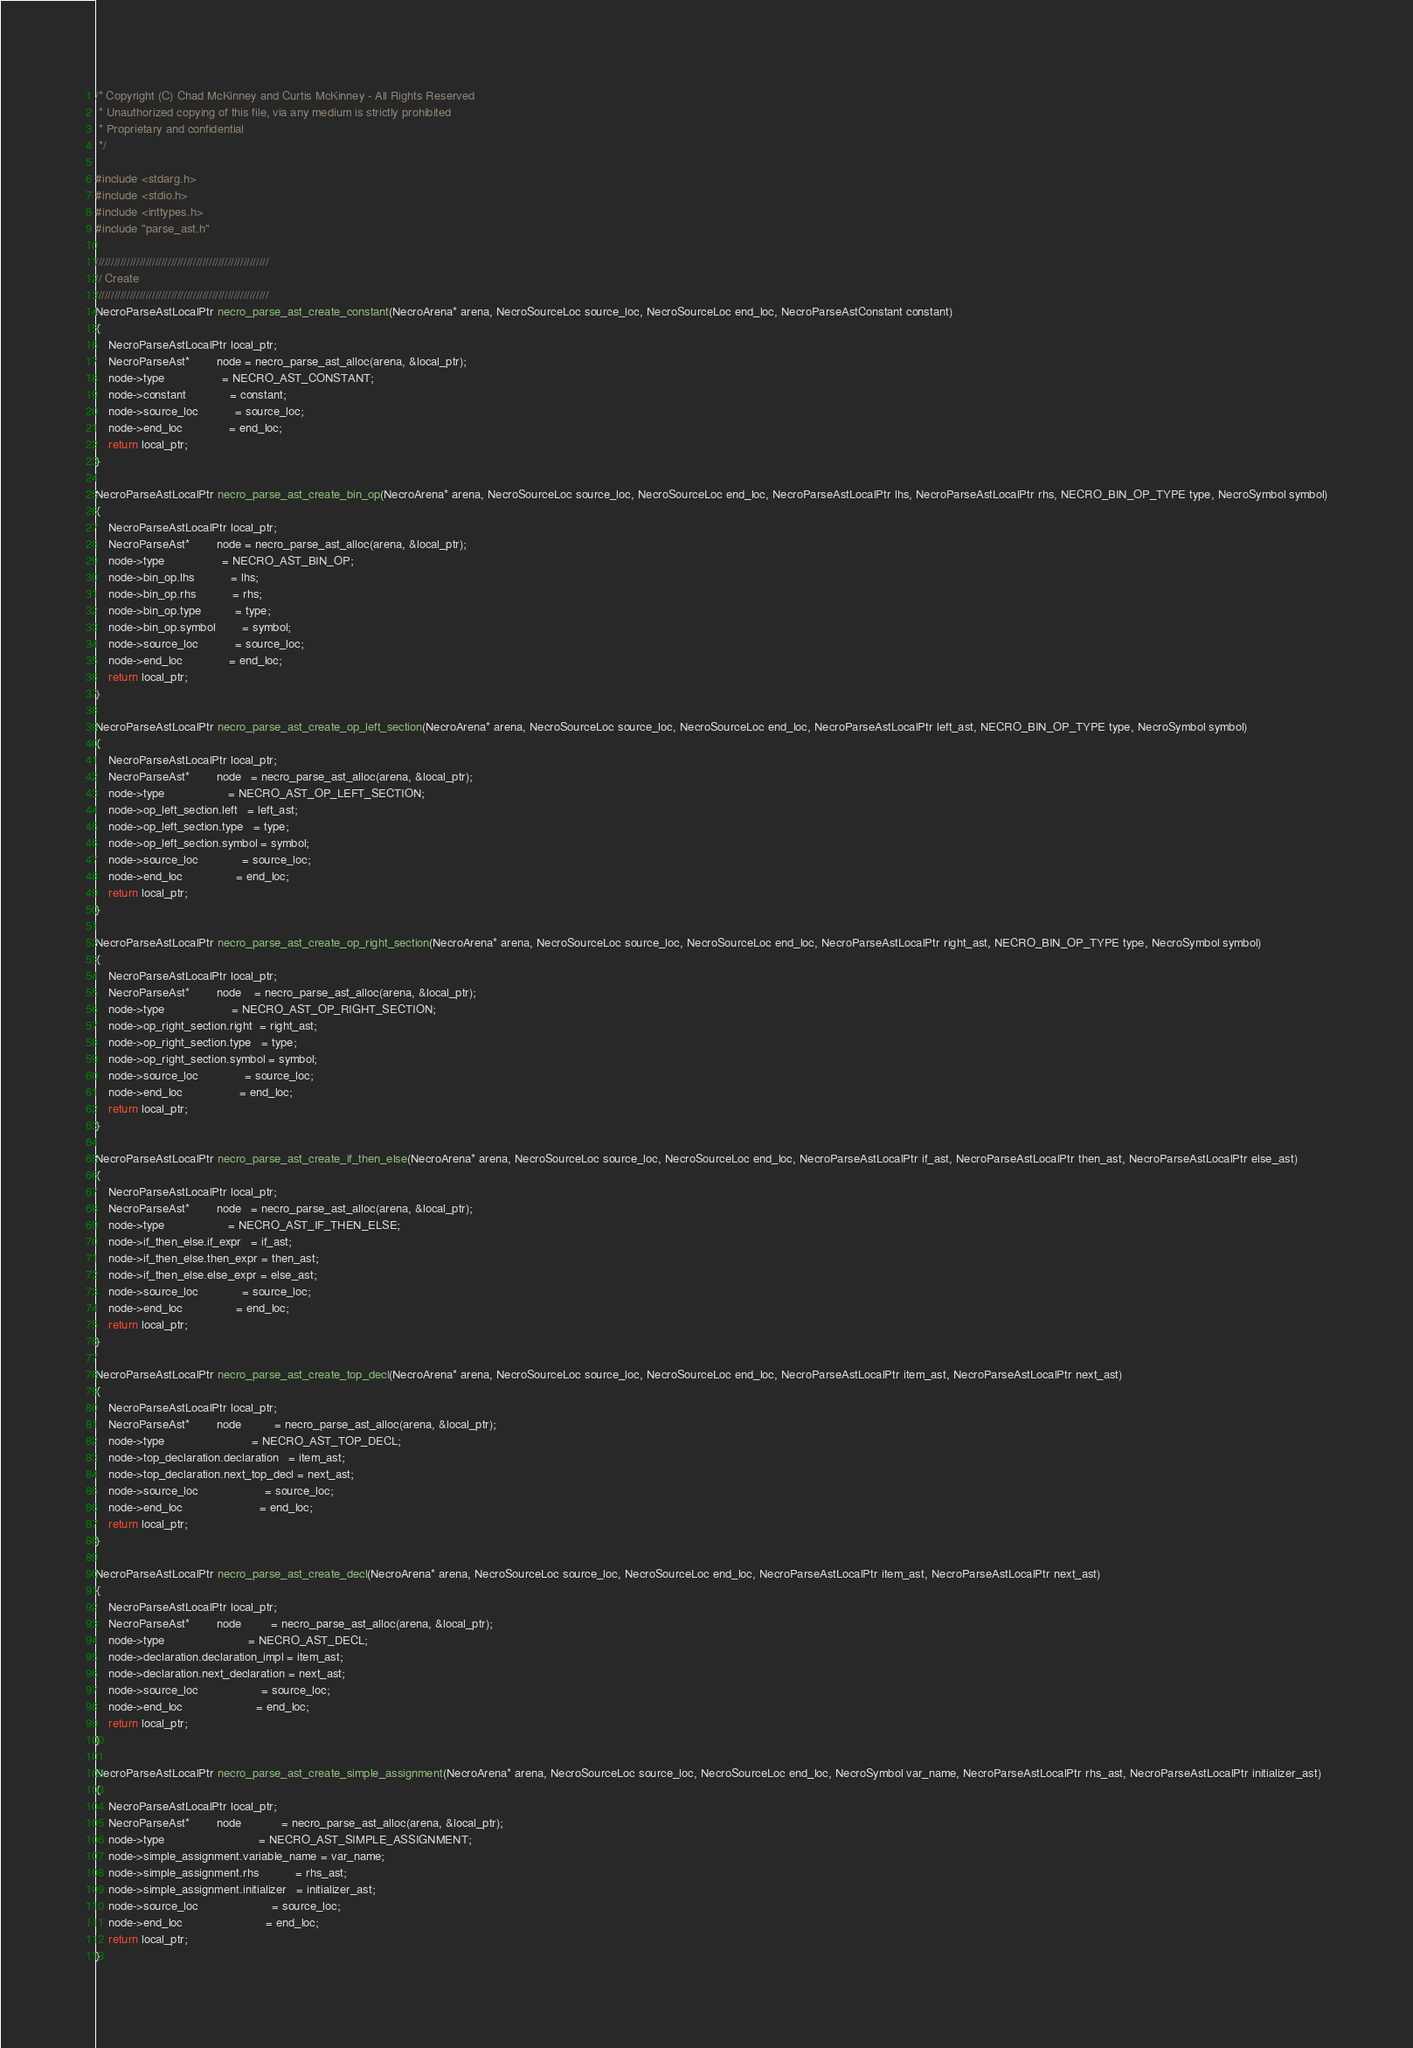<code> <loc_0><loc_0><loc_500><loc_500><_C_>/* Copyright (C) Chad McKinney and Curtis McKinney - All Rights Reserved
 * Unauthorized copying of this file, via any medium is strictly prohibited
 * Proprietary and confidential
 */

#include <stdarg.h>
#include <stdio.h>
#include <inttypes.h>
#include "parse_ast.h"

///////////////////////////////////////////////////////
// Create
///////////////////////////////////////////////////////
NecroParseAstLocalPtr necro_parse_ast_create_constant(NecroArena* arena, NecroSourceLoc source_loc, NecroSourceLoc end_loc, NecroParseAstConstant constant)
{
    NecroParseAstLocalPtr local_ptr;
    NecroParseAst*        node = necro_parse_ast_alloc(arena, &local_ptr);
    node->type                 = NECRO_AST_CONSTANT;
    node->constant             = constant;
    node->source_loc           = source_loc;
    node->end_loc              = end_loc;
    return local_ptr;
}

NecroParseAstLocalPtr necro_parse_ast_create_bin_op(NecroArena* arena, NecroSourceLoc source_loc, NecroSourceLoc end_loc, NecroParseAstLocalPtr lhs, NecroParseAstLocalPtr rhs, NECRO_BIN_OP_TYPE type, NecroSymbol symbol)
{
    NecroParseAstLocalPtr local_ptr;
    NecroParseAst*        node = necro_parse_ast_alloc(arena, &local_ptr);
    node->type                 = NECRO_AST_BIN_OP;
    node->bin_op.lhs           = lhs;
    node->bin_op.rhs           = rhs;
    node->bin_op.type          = type;
    node->bin_op.symbol        = symbol;
    node->source_loc           = source_loc;
    node->end_loc              = end_loc;
    return local_ptr;
}

NecroParseAstLocalPtr necro_parse_ast_create_op_left_section(NecroArena* arena, NecroSourceLoc source_loc, NecroSourceLoc end_loc, NecroParseAstLocalPtr left_ast, NECRO_BIN_OP_TYPE type, NecroSymbol symbol)
{
    NecroParseAstLocalPtr local_ptr;
    NecroParseAst*        node   = necro_parse_ast_alloc(arena, &local_ptr);
    node->type                   = NECRO_AST_OP_LEFT_SECTION;
    node->op_left_section.left   = left_ast;
    node->op_left_section.type   = type;
    node->op_left_section.symbol = symbol;
    node->source_loc             = source_loc;
    node->end_loc                = end_loc;
    return local_ptr;
}

NecroParseAstLocalPtr necro_parse_ast_create_op_right_section(NecroArena* arena, NecroSourceLoc source_loc, NecroSourceLoc end_loc, NecroParseAstLocalPtr right_ast, NECRO_BIN_OP_TYPE type, NecroSymbol symbol)
{
    NecroParseAstLocalPtr local_ptr;
    NecroParseAst*        node    = necro_parse_ast_alloc(arena, &local_ptr);
    node->type                    = NECRO_AST_OP_RIGHT_SECTION;
    node->op_right_section.right  = right_ast;
    node->op_right_section.type   = type;
    node->op_right_section.symbol = symbol;
    node->source_loc              = source_loc;
    node->end_loc                 = end_loc;
    return local_ptr;
}

NecroParseAstLocalPtr necro_parse_ast_create_if_then_else(NecroArena* arena, NecroSourceLoc source_loc, NecroSourceLoc end_loc, NecroParseAstLocalPtr if_ast, NecroParseAstLocalPtr then_ast, NecroParseAstLocalPtr else_ast)
{
    NecroParseAstLocalPtr local_ptr;
    NecroParseAst*        node   = necro_parse_ast_alloc(arena, &local_ptr);
    node->type                   = NECRO_AST_IF_THEN_ELSE;
    node->if_then_else.if_expr   = if_ast;
    node->if_then_else.then_expr = then_ast;
    node->if_then_else.else_expr = else_ast;
    node->source_loc             = source_loc;
    node->end_loc                = end_loc;
    return local_ptr;
}

NecroParseAstLocalPtr necro_parse_ast_create_top_decl(NecroArena* arena, NecroSourceLoc source_loc, NecroSourceLoc end_loc, NecroParseAstLocalPtr item_ast, NecroParseAstLocalPtr next_ast)
{
    NecroParseAstLocalPtr local_ptr;
    NecroParseAst*        node          = necro_parse_ast_alloc(arena, &local_ptr);
    node->type                          = NECRO_AST_TOP_DECL;
    node->top_declaration.declaration   = item_ast;
    node->top_declaration.next_top_decl = next_ast;
    node->source_loc                    = source_loc;
    node->end_loc                       = end_loc;
    return local_ptr;
}

NecroParseAstLocalPtr necro_parse_ast_create_decl(NecroArena* arena, NecroSourceLoc source_loc, NecroSourceLoc end_loc, NecroParseAstLocalPtr item_ast, NecroParseAstLocalPtr next_ast)
{
    NecroParseAstLocalPtr local_ptr;
    NecroParseAst*        node         = necro_parse_ast_alloc(arena, &local_ptr);
    node->type                         = NECRO_AST_DECL;
    node->declaration.declaration_impl = item_ast;
    node->declaration.next_declaration = next_ast;
    node->source_loc                   = source_loc;
    node->end_loc                      = end_loc;
    return local_ptr;
}

NecroParseAstLocalPtr necro_parse_ast_create_simple_assignment(NecroArena* arena, NecroSourceLoc source_loc, NecroSourceLoc end_loc, NecroSymbol var_name, NecroParseAstLocalPtr rhs_ast, NecroParseAstLocalPtr initializer_ast)
{
    NecroParseAstLocalPtr local_ptr;
    NecroParseAst*        node            = necro_parse_ast_alloc(arena, &local_ptr);
    node->type                            = NECRO_AST_SIMPLE_ASSIGNMENT;
    node->simple_assignment.variable_name = var_name;
    node->simple_assignment.rhs           = rhs_ast;
    node->simple_assignment.initializer   = initializer_ast;
    node->source_loc                      = source_loc;
    node->end_loc                         = end_loc;
    return local_ptr;
}
</code> 